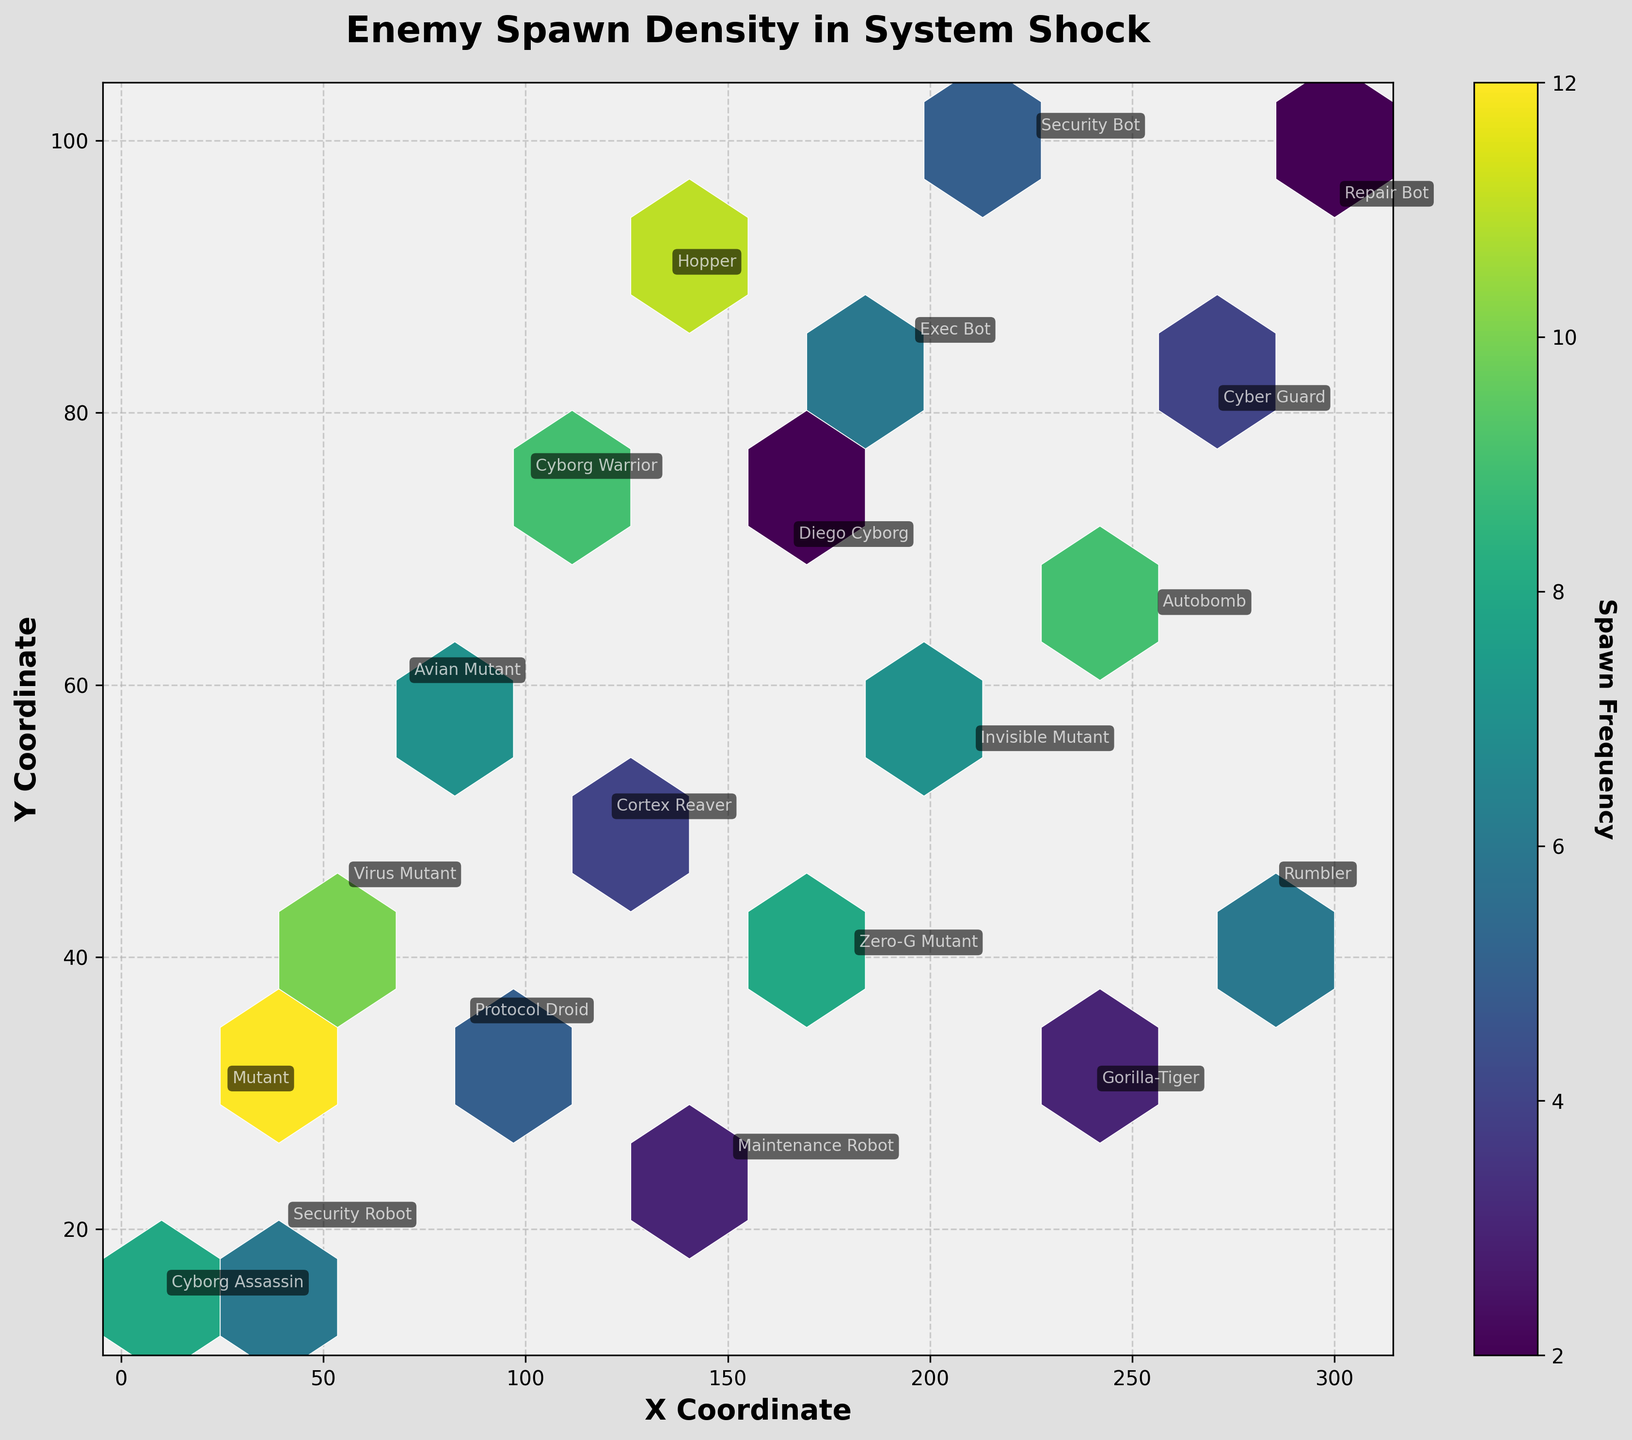What is the title of the figure? The title of the figure is usually found at the top of the chart and is often larger in size compared to other text elements. In this plot, the title "Enemy Spawn Density in System Shock" is prominently displayed.
Answer: Enemy Spawn Density in System Shock What are the X and Y coordinates that have the highest spawn frequency? To determine the highest spawn frequency, look for the hexagon with the most intense color. Hover over this part of the plot if necessary, but usually the color bar will give a good indication. In this case, the coordinates with the highest frequency are (25, 30).
Answer: (25, 30) How many different types of enemies are labeled in the plot? Count the number of different enemy type labels annotated on the plot. Each annotation represents a distinct type. There are 20 different enemy types labeled.
Answer: 20 Which enemy type has the second highest frequency and what is its frequent location on the plot? First, identify the highest frequency, which is 12 for the "Mutant." The second highest frequency is 11, for the "Hopper," found at coordinates (135, 90).
Answer: Hopper at (135, 90) What color represents the lowest spawn frequency and what value does it correspond to? To find the color representing the lowest spawn frequency, look at the color bar. The color associated with the lowest frequency is typically the lightest or least intense. In this plot, the lightest color corresponds to the frequency of 2.
Answer: Lightest color, 2 How do the spawn frequencies of "Cyborg Assassin" and "Security Bot" compare? Look at the annotations for "Cyborg Assassin" and "Security Bot." The "Cyborg Assassin" has a spawn frequency of 8, while the "Security Bot" has a frequency of 5. Therefore, the "Cyborg Assassin" spawns more frequently.
Answer: Cyborg Assassin spawns more frequently What is the sum of frequencies for enemies at the X coordinates 100 and 200? To determine this, find the frequencies of the enemies at X coordinates 100 and 200. The "Cyborg Warrior" at (100, 75) has a frequency of 9, and the "Security Bot" at (200, 55) has a frequency of 5. Thus, their sum is 9 + 5 = 14.
Answer: 14 Where on the plot is the "Invisible Mutant" located, and what is its frequency? Locate the "Invisible Mutant" annotation on the plot. The coordinates will provide the position: (210, 55), and the corresponding frequency is 7.
Answer: (210, 55), 7 Which enemy type has a frequency of 4, and what is its location on the plot? Identify the enemy type with a frequency of 4 by finding this value on the color scale and locating the corresponding annotation. "Cortex Reaver" at (120, 50) and "Cyber Guard" at (270, 80) both have this frequency.
Answer: Cortex Reaver at (120, 50) and Cyber Guard at (270, 80) What is the average frequency of enemies located below the Y coordinate of 50? Identify enemies below the Y coordinate 50 and sum their frequencies: Cyborg Assassin (8), Security Robot (6), Cortex Reaver (4), Maintenance Robot (3), Gorilla-Tiger (3), and Rumbler (6). The total is 30 with 6 enemies, so the average is 30/6 = 5.
Answer: 5 